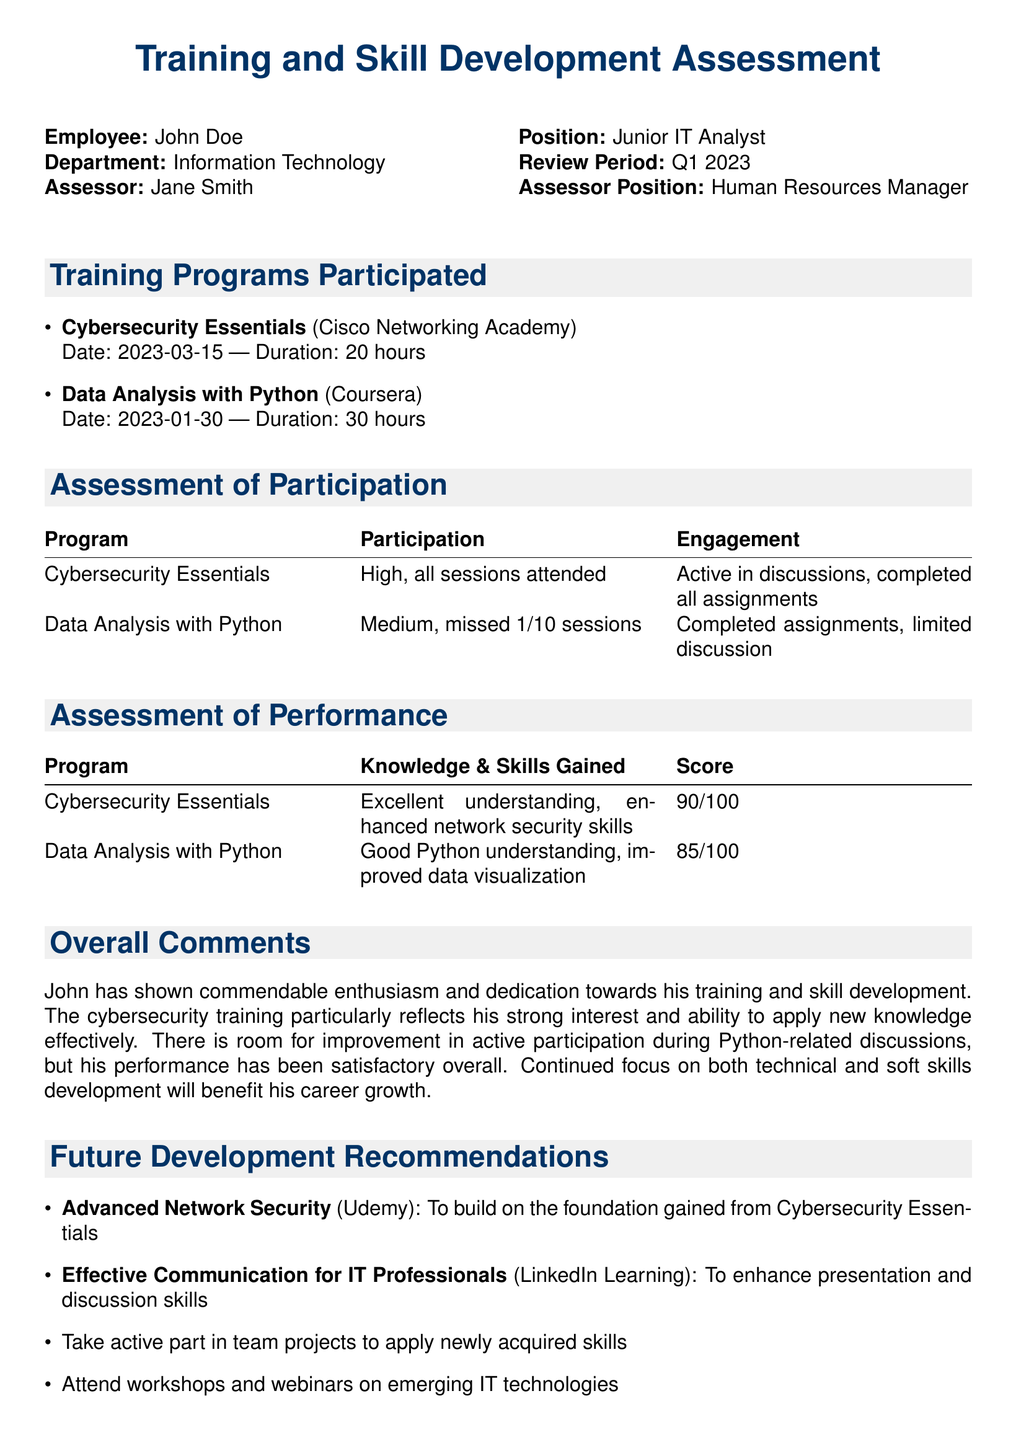What is the name of the employee? The document states that the employee's name is mentioned at the top under the employee details.
Answer: John Doe What position does the employee hold? The position of the employee is specified next to the name in the document.
Answer: Junior IT Analyst How many hours did the Cybersecurity Essentials program last? The duration of the Cybersecurity Essentials program is noted next to the program details.
Answer: 20 hours What score did John receive in the Data Analysis with Python program? The score for the Data Analysis with Python program is mentioned in the assessment of performance section.
Answer: 85/100 What is the primary focus of the recommended future development training? The document highlights key areas for future development training at the end of the assessment.
Answer: To enhance skills What type of assessment was given for participation in the Cybersecurity Essentials program? The level of participation in the Cybersecurity Essentials program is outlined in the participation assessment table.
Answer: High Which program had a medium level of engagement? The document lists the levels of engagement for each training program in the assessment of participation section.
Answer: Data Analysis with Python Who conducted the assessment? The name of the assessor is mentioned on the top of the document next to the employee's details.
Answer: Jane Smith What additional training is recommended to improve communication skills? The future development recommendations include various trainings, and this one is specifically noted for communication improvement.
Answer: Effective Communication for IT Professionals 